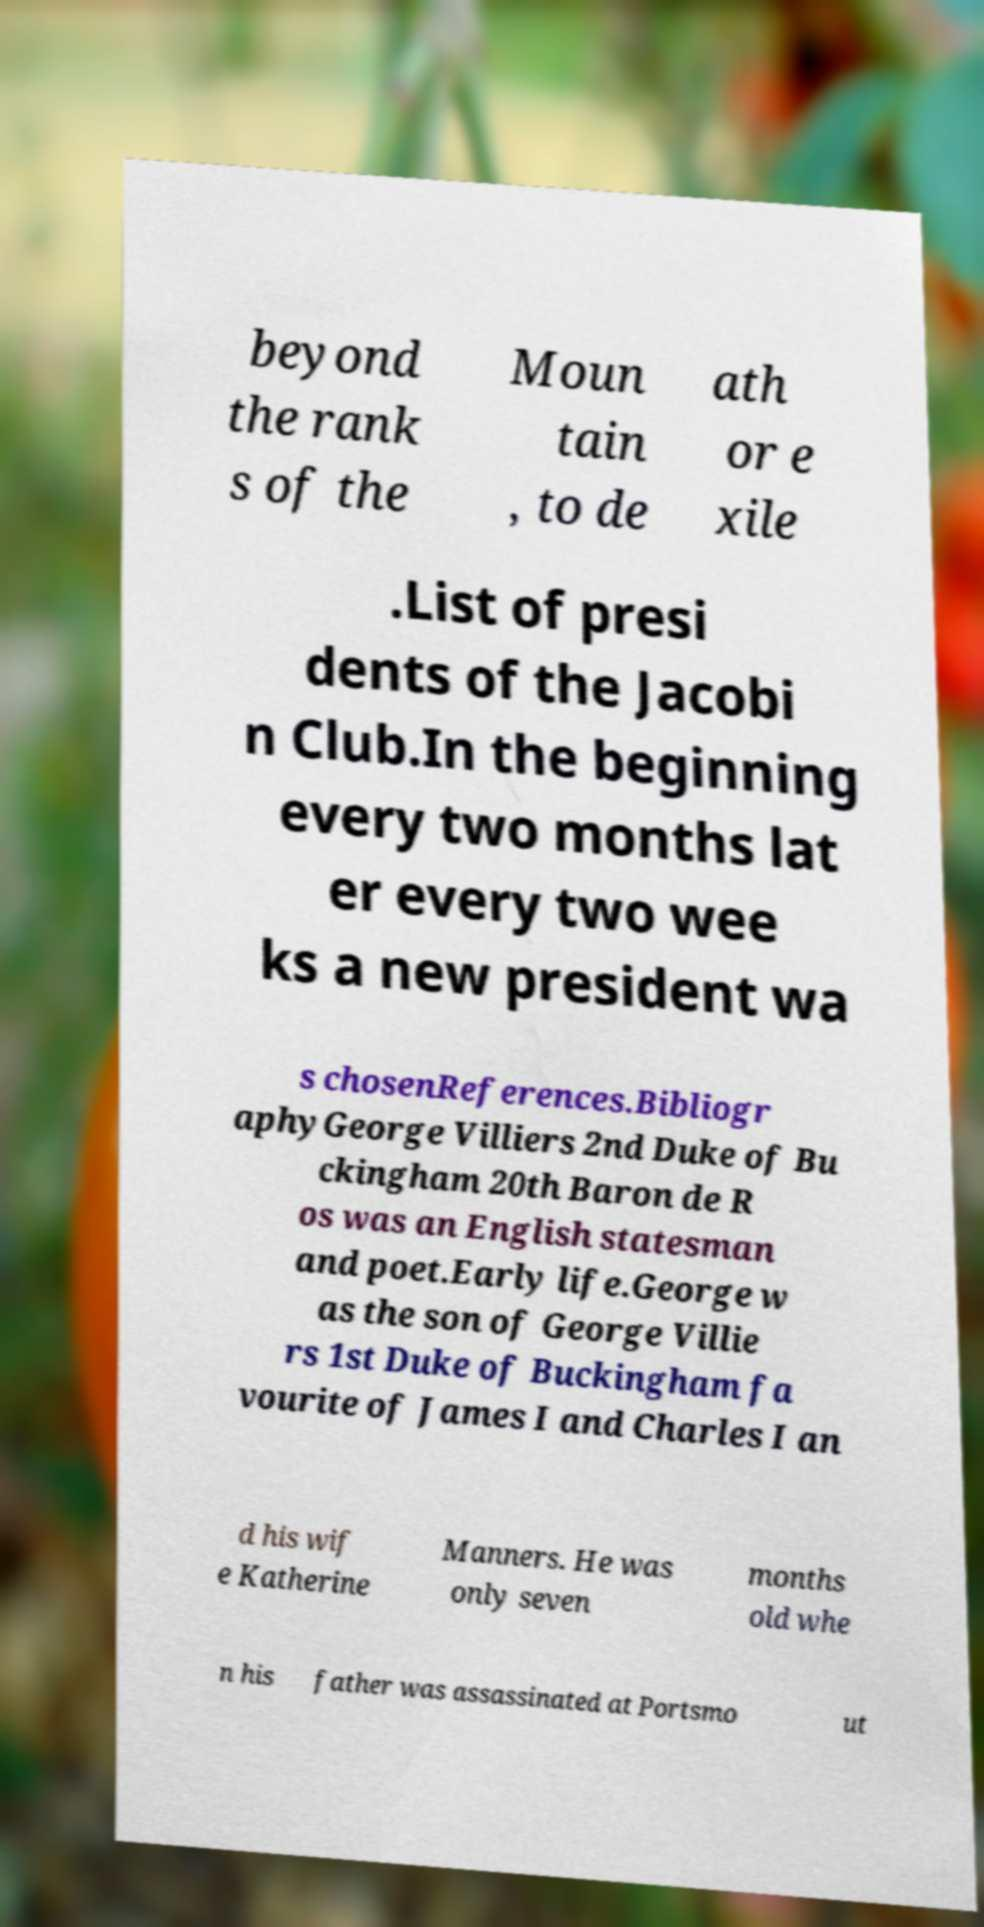Can you accurately transcribe the text from the provided image for me? beyond the rank s of the Moun tain , to de ath or e xile .List of presi dents of the Jacobi n Club.In the beginning every two months lat er every two wee ks a new president wa s chosenReferences.Bibliogr aphyGeorge Villiers 2nd Duke of Bu ckingham 20th Baron de R os was an English statesman and poet.Early life.George w as the son of George Villie rs 1st Duke of Buckingham fa vourite of James I and Charles I an d his wif e Katherine Manners. He was only seven months old whe n his father was assassinated at Portsmo ut 